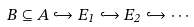<formula> <loc_0><loc_0><loc_500><loc_500>B \subseteq A \hookrightarrow E _ { 1 } \hookrightarrow E _ { 2 } \hookrightarrow \cdots</formula> 